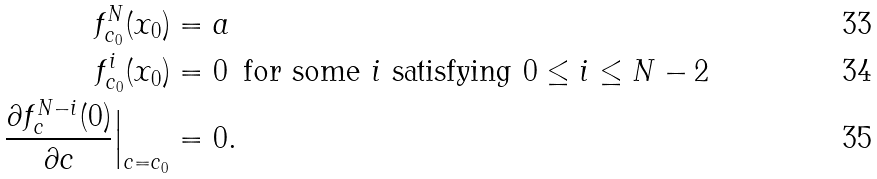Convert formula to latex. <formula><loc_0><loc_0><loc_500><loc_500>f _ { c _ { 0 } } ^ { N } ( x _ { 0 } ) & = a \\ f _ { c _ { 0 } } ^ { i } ( x _ { 0 } ) & = 0 \, \text { for some $i$ satisfying $0 \leq i \leq N-2$} \\ \frac { \partial f _ { c } ^ { N - i } ( 0 ) } { \partial c } \Big | _ { c = c _ { 0 } } & = 0 .</formula> 